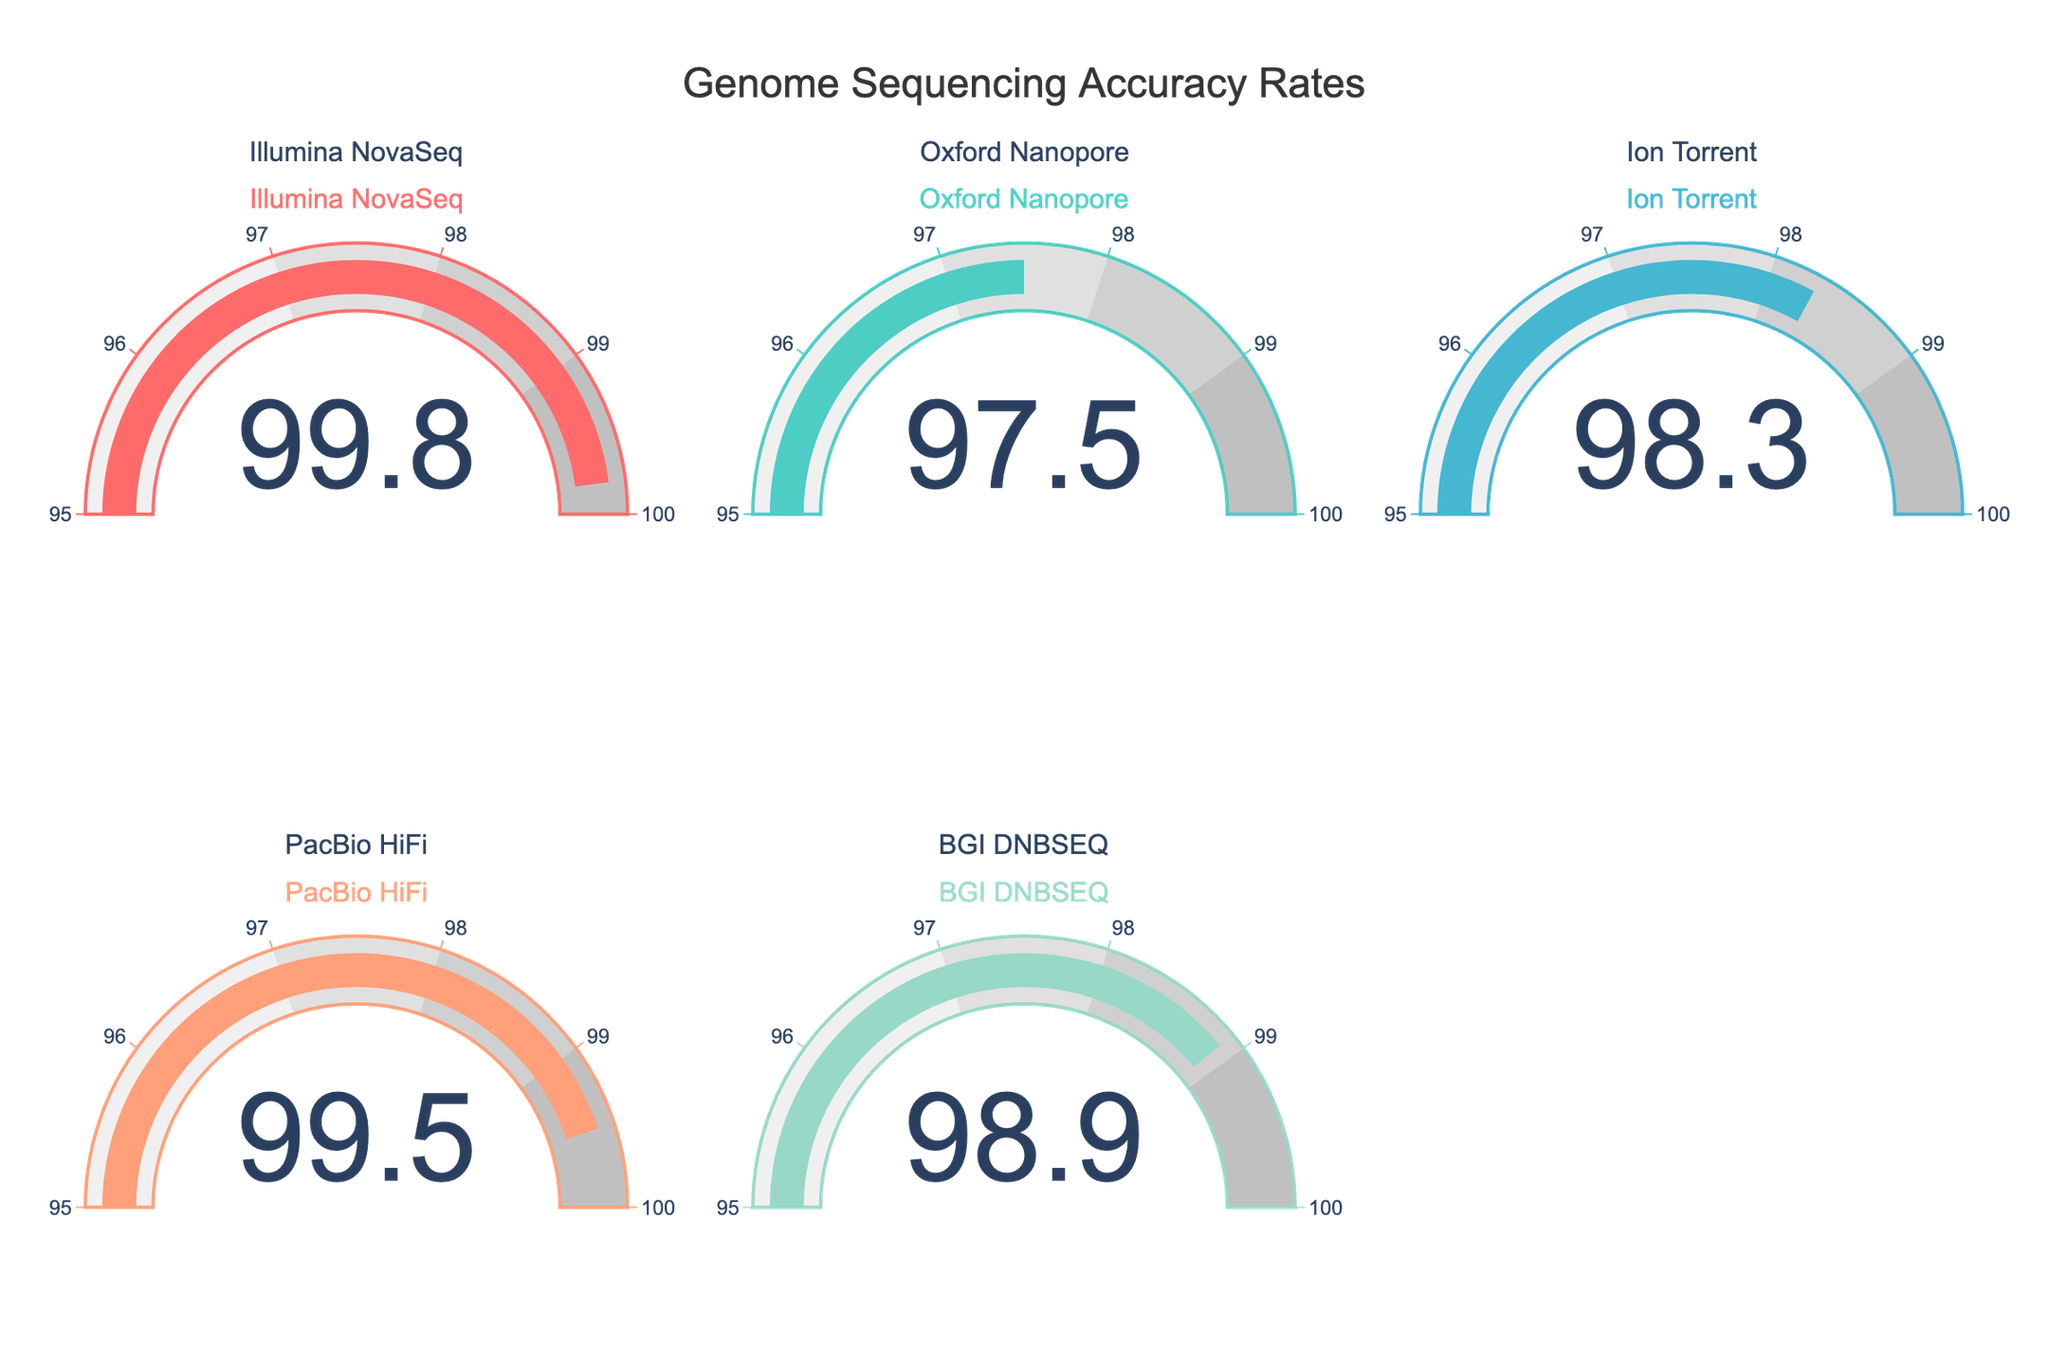What's the highest accuracy rate shown in the figure? To find the highest accuracy rate, look at the values displayed on each gauge. The highest value is 99.8, which corresponds to Illumina NovaSeq.
Answer: 99.8 Which technique has the lowest accuracy rate? To determine the lowest accuracy rate, check all the values on the gauges. The lowest value is 97.5, which corresponds to Oxford Nanopore.
Answer: Oxford Nanopore What is the difference in accuracy between the highest and lowest techniques? First, identify the highest accuracy (99.8 for Illumina NovaSeq) and the lowest accuracy (97.5 for Oxford Nanopore). Subtract the lowest from the highest: 99.8 - 97.5 = 2.3.
Answer: 2.3 What's the average accuracy rate across all techniques? Add all the accuracy values together and divide by the number of techniques: (99.8 + 97.5 + 98.3 + 99.5 + 98.9) / 5 = 98.8.
Answer: 98.8 Which techniques have an accuracy rate greater than 99? Look at each gauge and list the techniques with a value above 99. The techniques are Illumina NovaSeq and PacBio HiFi.
Answer: Illumina NovaSeq, PacBio HiFi How many techniques have an accuracy rate less than 98? Count the gauges with values below 98. There are two such techniques: Oxford Nanopore and Ion Torrent.
Answer: 2 Compare the accuracy of Ion Torrent and PacBio HiFi. Ion Torrent's accuracy is 98.3, while PacBio HiFi's accuracy is 99.5. PacBio HiFi has higher accuracy than Ion Torrent.
Answer: PacBio HiFi has higher accuracy What is the range of accuracy values in the figure? Find the difference between the highest (99.8 for Illumina NovaSeq) and the lowest (97.5 for Oxford Nanopore) accuracy values: 99.8 - 97.5 = 2.3.
Answer: 2.3 Which technique is second to the highest in accuracy? Identify the highest accuracy first (99.8 for Illumina NovaSeq), and then find the next highest value, which is 99.5 for PacBio HiFi.
Answer: PacBio HiFi Is the BGI DNBSEQ's accuracy closer to Ion Torrent or Oxford Nanopore? BGI DNBSEQ has an accuracy of 98.9. The difference from Ion Torrent (98.3) is 0.6, and from Oxford Nanopore (97.5) is 1.4. Since 0.6 < 1.4, BGI DNBSEQ's accuracy is closer to Ion Torrent.
Answer: Ion Torrent 